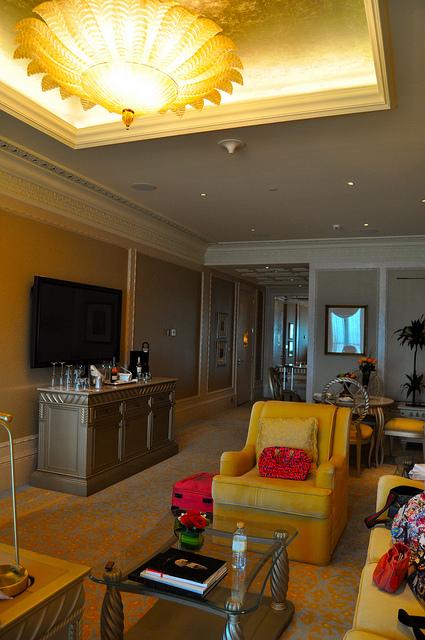Is the table made of wood?
Answer briefly. No. Is this a conventional living room?
Be succinct. Yes. Where is the red luggage?
Give a very brief answer. Floor. 